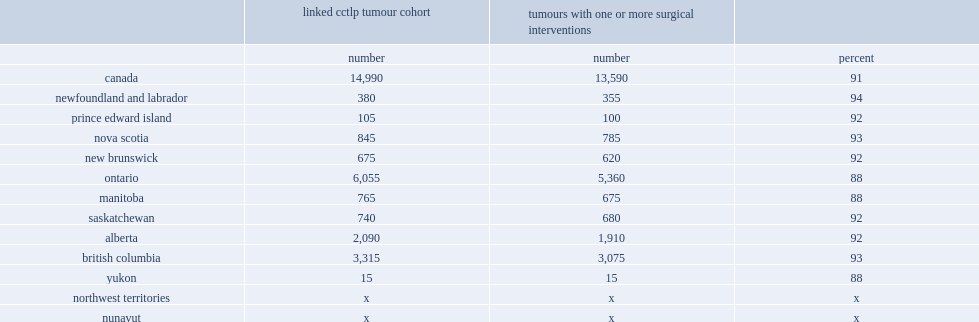Write the full table. {'header': ['', 'linked cctlp tumour cohort', 'tumours with one or more surgical interventions', ''], 'rows': [['', 'number', 'number', 'percent'], ['canada', '14,990', '13,590', '91'], ['newfoundland and labrador', '380', '355', '94'], ['prince edward island', '105', '100', '92'], ['nova scotia', '845', '785', '93'], ['new brunswick', '675', '620', '92'], ['ontario', '6,055', '5,360', '88'], ['manitoba', '765', '675', '88'], ['saskatchewan', '740', '680', '92'], ['alberta', '2,090', '1,910', '92'], ['british columbia', '3,315', '3,075', '93'], ['yukon', '15', '15', '88'], ['northwest territories', 'x', 'x', 'x'], ['nunavut', 'x', 'x', 'x']]} What is the rate of bladder tumours received surgical treatment? 91.0. List the provinces where 88% of bladder tumours received surgical treatment. Ontario manitoba yukon. What is the percentage of bladder tumours received surgical treatment in newfoundland and labrador? 94.0. 